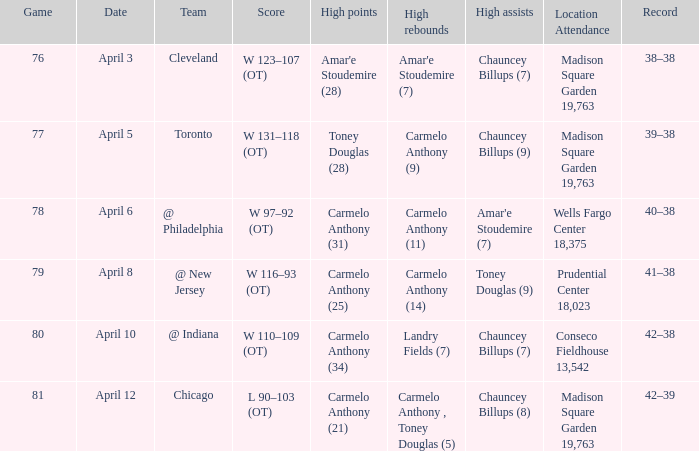Specify the date for cleveland. April 3. 